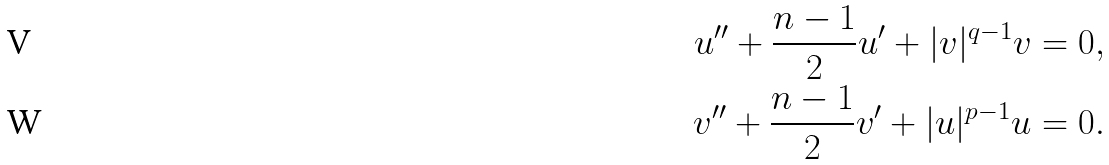Convert formula to latex. <formula><loc_0><loc_0><loc_500><loc_500>u ^ { \prime \prime } + \frac { n - 1 } { 2 } u ^ { \prime } + | v | ^ { q - 1 } v = 0 , \\ v ^ { \prime \prime } + \frac { n - 1 } { 2 } v ^ { \prime } + | u | ^ { p - 1 } u = 0 .</formula> 